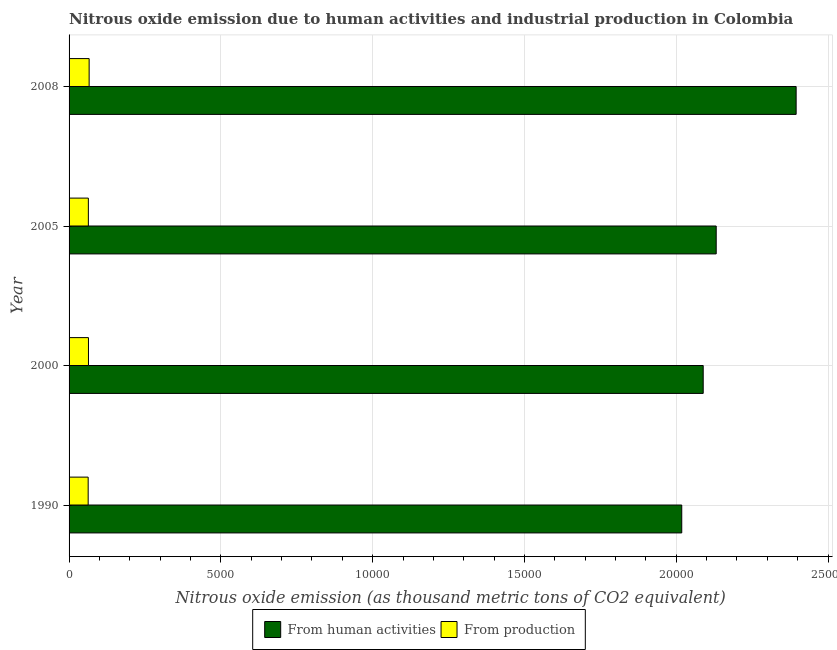Are the number of bars per tick equal to the number of legend labels?
Provide a short and direct response. Yes. Are the number of bars on each tick of the Y-axis equal?
Provide a short and direct response. Yes. How many bars are there on the 2nd tick from the top?
Your response must be concise. 2. What is the amount of emissions from human activities in 1990?
Make the answer very short. 2.02e+04. Across all years, what is the maximum amount of emissions generated from industries?
Offer a terse response. 661.1. Across all years, what is the minimum amount of emissions generated from industries?
Your response must be concise. 629.1. In which year was the amount of emissions generated from industries maximum?
Provide a succinct answer. 2008. In which year was the amount of emissions from human activities minimum?
Make the answer very short. 1990. What is the total amount of emissions generated from industries in the graph?
Your response must be concise. 2564.3. What is the difference between the amount of emissions generated from industries in 2000 and that in 2008?
Keep it short and to the point. -22.3. What is the difference between the amount of emissions from human activities in 2000 and the amount of emissions generated from industries in 2005?
Provide a succinct answer. 2.03e+04. What is the average amount of emissions from human activities per year?
Offer a terse response. 2.16e+04. In the year 1990, what is the difference between the amount of emissions from human activities and amount of emissions generated from industries?
Provide a succinct answer. 1.96e+04. What is the ratio of the amount of emissions from human activities in 1990 to that in 2005?
Provide a succinct answer. 0.95. Is the amount of emissions generated from industries in 1990 less than that in 2008?
Ensure brevity in your answer.  Yes. Is the difference between the amount of emissions generated from industries in 1990 and 2005 greater than the difference between the amount of emissions from human activities in 1990 and 2005?
Provide a short and direct response. Yes. What is the difference between the highest and the second highest amount of emissions generated from industries?
Ensure brevity in your answer.  22.3. What is the difference between the highest and the lowest amount of emissions from human activities?
Give a very brief answer. 3767.8. In how many years, is the amount of emissions generated from industries greater than the average amount of emissions generated from industries taken over all years?
Keep it short and to the point. 1. Is the sum of the amount of emissions generated from industries in 1990 and 2005 greater than the maximum amount of emissions from human activities across all years?
Ensure brevity in your answer.  No. What does the 1st bar from the top in 2008 represents?
Make the answer very short. From production. What does the 1st bar from the bottom in 2000 represents?
Provide a short and direct response. From human activities. How many bars are there?
Your response must be concise. 8. Are all the bars in the graph horizontal?
Your answer should be very brief. Yes. How many years are there in the graph?
Your answer should be very brief. 4. What is the difference between two consecutive major ticks on the X-axis?
Provide a succinct answer. 5000. Does the graph contain any zero values?
Keep it short and to the point. No. Does the graph contain grids?
Make the answer very short. Yes. How many legend labels are there?
Your answer should be compact. 2. How are the legend labels stacked?
Keep it short and to the point. Horizontal. What is the title of the graph?
Your response must be concise. Nitrous oxide emission due to human activities and industrial production in Colombia. What is the label or title of the X-axis?
Ensure brevity in your answer.  Nitrous oxide emission (as thousand metric tons of CO2 equivalent). What is the label or title of the Y-axis?
Keep it short and to the point. Year. What is the Nitrous oxide emission (as thousand metric tons of CO2 equivalent) of From human activities in 1990?
Keep it short and to the point. 2.02e+04. What is the Nitrous oxide emission (as thousand metric tons of CO2 equivalent) in From production in 1990?
Ensure brevity in your answer.  629.1. What is the Nitrous oxide emission (as thousand metric tons of CO2 equivalent) of From human activities in 2000?
Your answer should be very brief. 2.09e+04. What is the Nitrous oxide emission (as thousand metric tons of CO2 equivalent) in From production in 2000?
Offer a very short reply. 638.8. What is the Nitrous oxide emission (as thousand metric tons of CO2 equivalent) of From human activities in 2005?
Offer a very short reply. 2.13e+04. What is the Nitrous oxide emission (as thousand metric tons of CO2 equivalent) in From production in 2005?
Your answer should be compact. 635.3. What is the Nitrous oxide emission (as thousand metric tons of CO2 equivalent) of From human activities in 2008?
Your answer should be compact. 2.39e+04. What is the Nitrous oxide emission (as thousand metric tons of CO2 equivalent) of From production in 2008?
Your answer should be very brief. 661.1. Across all years, what is the maximum Nitrous oxide emission (as thousand metric tons of CO2 equivalent) in From human activities?
Ensure brevity in your answer.  2.39e+04. Across all years, what is the maximum Nitrous oxide emission (as thousand metric tons of CO2 equivalent) of From production?
Make the answer very short. 661.1. Across all years, what is the minimum Nitrous oxide emission (as thousand metric tons of CO2 equivalent) of From human activities?
Keep it short and to the point. 2.02e+04. Across all years, what is the minimum Nitrous oxide emission (as thousand metric tons of CO2 equivalent) in From production?
Your response must be concise. 629.1. What is the total Nitrous oxide emission (as thousand metric tons of CO2 equivalent) in From human activities in the graph?
Ensure brevity in your answer.  8.63e+04. What is the total Nitrous oxide emission (as thousand metric tons of CO2 equivalent) of From production in the graph?
Offer a very short reply. 2564.3. What is the difference between the Nitrous oxide emission (as thousand metric tons of CO2 equivalent) of From human activities in 1990 and that in 2000?
Make the answer very short. -706.7. What is the difference between the Nitrous oxide emission (as thousand metric tons of CO2 equivalent) in From production in 1990 and that in 2000?
Ensure brevity in your answer.  -9.7. What is the difference between the Nitrous oxide emission (as thousand metric tons of CO2 equivalent) of From human activities in 1990 and that in 2005?
Offer a very short reply. -1134.8. What is the difference between the Nitrous oxide emission (as thousand metric tons of CO2 equivalent) of From human activities in 1990 and that in 2008?
Give a very brief answer. -3767.8. What is the difference between the Nitrous oxide emission (as thousand metric tons of CO2 equivalent) of From production in 1990 and that in 2008?
Provide a short and direct response. -32. What is the difference between the Nitrous oxide emission (as thousand metric tons of CO2 equivalent) in From human activities in 2000 and that in 2005?
Your answer should be compact. -428.1. What is the difference between the Nitrous oxide emission (as thousand metric tons of CO2 equivalent) in From human activities in 2000 and that in 2008?
Make the answer very short. -3061.1. What is the difference between the Nitrous oxide emission (as thousand metric tons of CO2 equivalent) of From production in 2000 and that in 2008?
Offer a very short reply. -22.3. What is the difference between the Nitrous oxide emission (as thousand metric tons of CO2 equivalent) in From human activities in 2005 and that in 2008?
Offer a terse response. -2633. What is the difference between the Nitrous oxide emission (as thousand metric tons of CO2 equivalent) of From production in 2005 and that in 2008?
Your response must be concise. -25.8. What is the difference between the Nitrous oxide emission (as thousand metric tons of CO2 equivalent) of From human activities in 1990 and the Nitrous oxide emission (as thousand metric tons of CO2 equivalent) of From production in 2000?
Your response must be concise. 1.95e+04. What is the difference between the Nitrous oxide emission (as thousand metric tons of CO2 equivalent) in From human activities in 1990 and the Nitrous oxide emission (as thousand metric tons of CO2 equivalent) in From production in 2005?
Make the answer very short. 1.95e+04. What is the difference between the Nitrous oxide emission (as thousand metric tons of CO2 equivalent) of From human activities in 1990 and the Nitrous oxide emission (as thousand metric tons of CO2 equivalent) of From production in 2008?
Keep it short and to the point. 1.95e+04. What is the difference between the Nitrous oxide emission (as thousand metric tons of CO2 equivalent) in From human activities in 2000 and the Nitrous oxide emission (as thousand metric tons of CO2 equivalent) in From production in 2005?
Give a very brief answer. 2.03e+04. What is the difference between the Nitrous oxide emission (as thousand metric tons of CO2 equivalent) of From human activities in 2000 and the Nitrous oxide emission (as thousand metric tons of CO2 equivalent) of From production in 2008?
Ensure brevity in your answer.  2.02e+04. What is the difference between the Nitrous oxide emission (as thousand metric tons of CO2 equivalent) of From human activities in 2005 and the Nitrous oxide emission (as thousand metric tons of CO2 equivalent) of From production in 2008?
Ensure brevity in your answer.  2.07e+04. What is the average Nitrous oxide emission (as thousand metric tons of CO2 equivalent) in From human activities per year?
Your answer should be very brief. 2.16e+04. What is the average Nitrous oxide emission (as thousand metric tons of CO2 equivalent) in From production per year?
Provide a short and direct response. 641.08. In the year 1990, what is the difference between the Nitrous oxide emission (as thousand metric tons of CO2 equivalent) in From human activities and Nitrous oxide emission (as thousand metric tons of CO2 equivalent) in From production?
Your response must be concise. 1.96e+04. In the year 2000, what is the difference between the Nitrous oxide emission (as thousand metric tons of CO2 equivalent) in From human activities and Nitrous oxide emission (as thousand metric tons of CO2 equivalent) in From production?
Make the answer very short. 2.02e+04. In the year 2005, what is the difference between the Nitrous oxide emission (as thousand metric tons of CO2 equivalent) of From human activities and Nitrous oxide emission (as thousand metric tons of CO2 equivalent) of From production?
Keep it short and to the point. 2.07e+04. In the year 2008, what is the difference between the Nitrous oxide emission (as thousand metric tons of CO2 equivalent) in From human activities and Nitrous oxide emission (as thousand metric tons of CO2 equivalent) in From production?
Offer a very short reply. 2.33e+04. What is the ratio of the Nitrous oxide emission (as thousand metric tons of CO2 equivalent) of From human activities in 1990 to that in 2000?
Give a very brief answer. 0.97. What is the ratio of the Nitrous oxide emission (as thousand metric tons of CO2 equivalent) of From production in 1990 to that in 2000?
Provide a succinct answer. 0.98. What is the ratio of the Nitrous oxide emission (as thousand metric tons of CO2 equivalent) in From human activities in 1990 to that in 2005?
Give a very brief answer. 0.95. What is the ratio of the Nitrous oxide emission (as thousand metric tons of CO2 equivalent) in From production in 1990 to that in 2005?
Make the answer very short. 0.99. What is the ratio of the Nitrous oxide emission (as thousand metric tons of CO2 equivalent) of From human activities in 1990 to that in 2008?
Make the answer very short. 0.84. What is the ratio of the Nitrous oxide emission (as thousand metric tons of CO2 equivalent) of From production in 1990 to that in 2008?
Your answer should be compact. 0.95. What is the ratio of the Nitrous oxide emission (as thousand metric tons of CO2 equivalent) in From human activities in 2000 to that in 2005?
Your answer should be very brief. 0.98. What is the ratio of the Nitrous oxide emission (as thousand metric tons of CO2 equivalent) in From production in 2000 to that in 2005?
Make the answer very short. 1.01. What is the ratio of the Nitrous oxide emission (as thousand metric tons of CO2 equivalent) in From human activities in 2000 to that in 2008?
Keep it short and to the point. 0.87. What is the ratio of the Nitrous oxide emission (as thousand metric tons of CO2 equivalent) of From production in 2000 to that in 2008?
Provide a succinct answer. 0.97. What is the ratio of the Nitrous oxide emission (as thousand metric tons of CO2 equivalent) of From human activities in 2005 to that in 2008?
Provide a succinct answer. 0.89. What is the difference between the highest and the second highest Nitrous oxide emission (as thousand metric tons of CO2 equivalent) of From human activities?
Provide a short and direct response. 2633. What is the difference between the highest and the second highest Nitrous oxide emission (as thousand metric tons of CO2 equivalent) of From production?
Make the answer very short. 22.3. What is the difference between the highest and the lowest Nitrous oxide emission (as thousand metric tons of CO2 equivalent) of From human activities?
Ensure brevity in your answer.  3767.8. What is the difference between the highest and the lowest Nitrous oxide emission (as thousand metric tons of CO2 equivalent) of From production?
Make the answer very short. 32. 